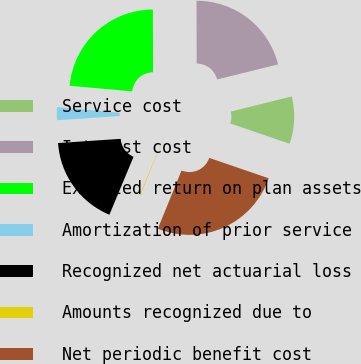<chart> <loc_0><loc_0><loc_500><loc_500><pie_chart><fcel>Service cost<fcel>Interest cost<fcel>Expected return on plan assets<fcel>Amortization of prior service<fcel>Recognized net actuarial loss<fcel>Amounts recognized due to<fcel>Net periodic benefit cost<nl><fcel>9.12%<fcel>21.17%<fcel>23.53%<fcel>2.5%<fcel>17.64%<fcel>0.14%<fcel>25.89%<nl></chart> 